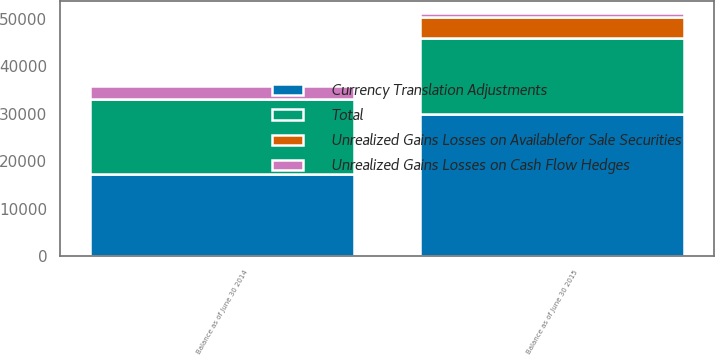Convert chart. <chart><loc_0><loc_0><loc_500><loc_500><stacked_bar_chart><ecel><fcel>Balance as of June 30 2015<fcel>Balance as of June 30 2014<nl><fcel>Currency Translation Adjustments<fcel>29925<fcel>17271<nl><fcel>Unrealized Gains Losses on Cash Flow Hedges<fcel>734<fcel>2800<nl><fcel>Unrealized Gains Losses on Availablefor Sale Securities<fcel>4553<fcel>12<nl><fcel>Total<fcel>15935<fcel>15788<nl></chart> 